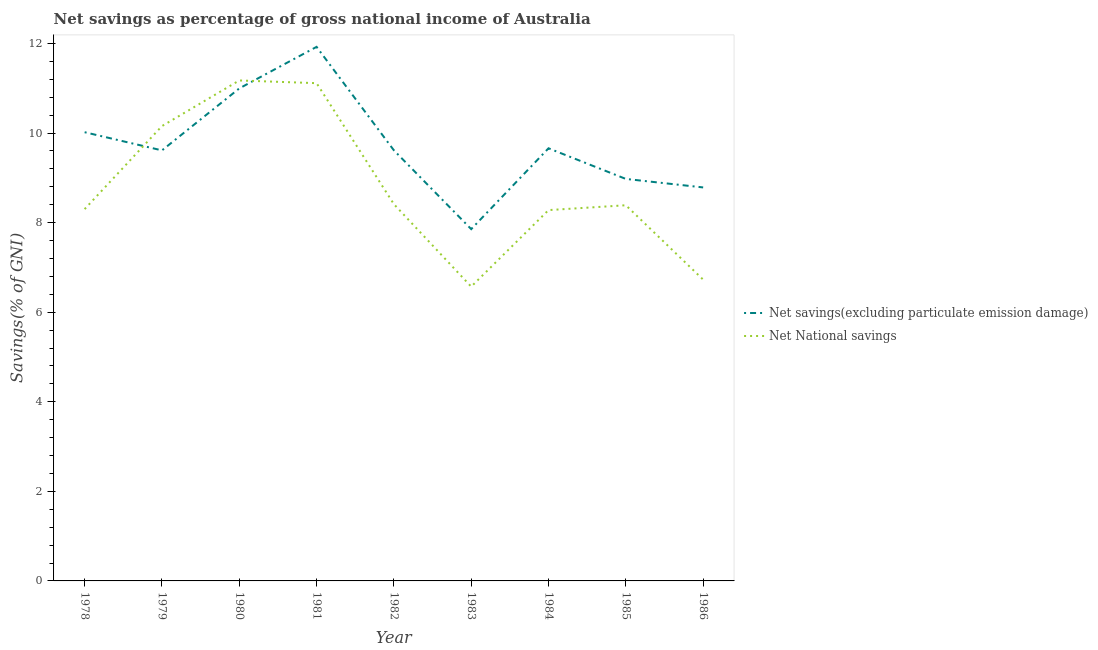Does the line corresponding to net savings(excluding particulate emission damage) intersect with the line corresponding to net national savings?
Your answer should be very brief. Yes. What is the net national savings in 1978?
Make the answer very short. 8.3. Across all years, what is the maximum net savings(excluding particulate emission damage)?
Your answer should be compact. 11.92. Across all years, what is the minimum net national savings?
Provide a succinct answer. 6.57. In which year was the net savings(excluding particulate emission damage) maximum?
Offer a terse response. 1981. In which year was the net savings(excluding particulate emission damage) minimum?
Your answer should be very brief. 1983. What is the total net national savings in the graph?
Provide a succinct answer. 79.13. What is the difference between the net savings(excluding particulate emission damage) in 1979 and that in 1986?
Ensure brevity in your answer.  0.83. What is the difference between the net savings(excluding particulate emission damage) in 1983 and the net national savings in 1982?
Keep it short and to the point. -0.56. What is the average net savings(excluding particulate emission damage) per year?
Offer a very short reply. 9.72. In the year 1979, what is the difference between the net savings(excluding particulate emission damage) and net national savings?
Offer a very short reply. -0.54. What is the ratio of the net national savings in 1978 to that in 1982?
Offer a terse response. 0.99. What is the difference between the highest and the second highest net national savings?
Provide a short and direct response. 0.06. What is the difference between the highest and the lowest net national savings?
Your answer should be compact. 4.6. In how many years, is the net savings(excluding particulate emission damage) greater than the average net savings(excluding particulate emission damage) taken over all years?
Your answer should be very brief. 3. Is the sum of the net savings(excluding particulate emission damage) in 1982 and 1985 greater than the maximum net national savings across all years?
Your answer should be very brief. Yes. Does the net savings(excluding particulate emission damage) monotonically increase over the years?
Offer a very short reply. No. Is the net savings(excluding particulate emission damage) strictly greater than the net national savings over the years?
Keep it short and to the point. No. Is the net national savings strictly less than the net savings(excluding particulate emission damage) over the years?
Offer a terse response. No. How many lines are there?
Provide a succinct answer. 2. Are the values on the major ticks of Y-axis written in scientific E-notation?
Provide a succinct answer. No. Does the graph contain grids?
Ensure brevity in your answer.  No. Where does the legend appear in the graph?
Your answer should be very brief. Center right. How are the legend labels stacked?
Offer a very short reply. Vertical. What is the title of the graph?
Provide a succinct answer. Net savings as percentage of gross national income of Australia. Does "Tetanus" appear as one of the legend labels in the graph?
Provide a succinct answer. No. What is the label or title of the Y-axis?
Provide a succinct answer. Savings(% of GNI). What is the Savings(% of GNI) in Net savings(excluding particulate emission damage) in 1978?
Ensure brevity in your answer.  10.02. What is the Savings(% of GNI) of Net National savings in 1978?
Keep it short and to the point. 8.3. What is the Savings(% of GNI) of Net savings(excluding particulate emission damage) in 1979?
Give a very brief answer. 9.61. What is the Savings(% of GNI) of Net National savings in 1979?
Offer a terse response. 10.16. What is the Savings(% of GNI) in Net savings(excluding particulate emission damage) in 1980?
Provide a succinct answer. 11. What is the Savings(% of GNI) of Net National savings in 1980?
Keep it short and to the point. 11.17. What is the Savings(% of GNI) of Net savings(excluding particulate emission damage) in 1981?
Your response must be concise. 11.92. What is the Savings(% of GNI) in Net National savings in 1981?
Provide a short and direct response. 11.11. What is the Savings(% of GNI) in Net savings(excluding particulate emission damage) in 1982?
Your response must be concise. 9.61. What is the Savings(% of GNI) in Net National savings in 1982?
Your answer should be compact. 8.41. What is the Savings(% of GNI) in Net savings(excluding particulate emission damage) in 1983?
Provide a short and direct response. 7.85. What is the Savings(% of GNI) in Net National savings in 1983?
Make the answer very short. 6.57. What is the Savings(% of GNI) in Net savings(excluding particulate emission damage) in 1984?
Offer a very short reply. 9.66. What is the Savings(% of GNI) in Net National savings in 1984?
Give a very brief answer. 8.28. What is the Savings(% of GNI) in Net savings(excluding particulate emission damage) in 1985?
Give a very brief answer. 8.98. What is the Savings(% of GNI) in Net National savings in 1985?
Provide a succinct answer. 8.39. What is the Savings(% of GNI) of Net savings(excluding particulate emission damage) in 1986?
Ensure brevity in your answer.  8.79. What is the Savings(% of GNI) in Net National savings in 1986?
Your response must be concise. 6.73. Across all years, what is the maximum Savings(% of GNI) in Net savings(excluding particulate emission damage)?
Your answer should be very brief. 11.92. Across all years, what is the maximum Savings(% of GNI) in Net National savings?
Ensure brevity in your answer.  11.17. Across all years, what is the minimum Savings(% of GNI) of Net savings(excluding particulate emission damage)?
Offer a terse response. 7.85. Across all years, what is the minimum Savings(% of GNI) of Net National savings?
Make the answer very short. 6.57. What is the total Savings(% of GNI) in Net savings(excluding particulate emission damage) in the graph?
Give a very brief answer. 87.45. What is the total Savings(% of GNI) of Net National savings in the graph?
Provide a short and direct response. 79.13. What is the difference between the Savings(% of GNI) in Net savings(excluding particulate emission damage) in 1978 and that in 1979?
Provide a short and direct response. 0.41. What is the difference between the Savings(% of GNI) in Net National savings in 1978 and that in 1979?
Your answer should be compact. -1.85. What is the difference between the Savings(% of GNI) of Net savings(excluding particulate emission damage) in 1978 and that in 1980?
Your answer should be compact. -0.98. What is the difference between the Savings(% of GNI) of Net National savings in 1978 and that in 1980?
Your response must be concise. -2.87. What is the difference between the Savings(% of GNI) of Net savings(excluding particulate emission damage) in 1978 and that in 1981?
Provide a short and direct response. -1.91. What is the difference between the Savings(% of GNI) of Net National savings in 1978 and that in 1981?
Your answer should be very brief. -2.81. What is the difference between the Savings(% of GNI) of Net savings(excluding particulate emission damage) in 1978 and that in 1982?
Make the answer very short. 0.4. What is the difference between the Savings(% of GNI) of Net National savings in 1978 and that in 1982?
Ensure brevity in your answer.  -0.11. What is the difference between the Savings(% of GNI) of Net savings(excluding particulate emission damage) in 1978 and that in 1983?
Your answer should be compact. 2.16. What is the difference between the Savings(% of GNI) in Net National savings in 1978 and that in 1983?
Your answer should be compact. 1.73. What is the difference between the Savings(% of GNI) of Net savings(excluding particulate emission damage) in 1978 and that in 1984?
Give a very brief answer. 0.36. What is the difference between the Savings(% of GNI) in Net National savings in 1978 and that in 1984?
Your answer should be compact. 0.02. What is the difference between the Savings(% of GNI) of Net savings(excluding particulate emission damage) in 1978 and that in 1985?
Provide a short and direct response. 1.04. What is the difference between the Savings(% of GNI) in Net National savings in 1978 and that in 1985?
Ensure brevity in your answer.  -0.09. What is the difference between the Savings(% of GNI) in Net savings(excluding particulate emission damage) in 1978 and that in 1986?
Keep it short and to the point. 1.23. What is the difference between the Savings(% of GNI) of Net National savings in 1978 and that in 1986?
Keep it short and to the point. 1.57. What is the difference between the Savings(% of GNI) of Net savings(excluding particulate emission damage) in 1979 and that in 1980?
Your response must be concise. -1.38. What is the difference between the Savings(% of GNI) of Net National savings in 1979 and that in 1980?
Make the answer very short. -1.02. What is the difference between the Savings(% of GNI) in Net savings(excluding particulate emission damage) in 1979 and that in 1981?
Offer a terse response. -2.31. What is the difference between the Savings(% of GNI) in Net National savings in 1979 and that in 1981?
Provide a succinct answer. -0.96. What is the difference between the Savings(% of GNI) of Net savings(excluding particulate emission damage) in 1979 and that in 1982?
Ensure brevity in your answer.  -0. What is the difference between the Savings(% of GNI) of Net National savings in 1979 and that in 1982?
Make the answer very short. 1.74. What is the difference between the Savings(% of GNI) in Net savings(excluding particulate emission damage) in 1979 and that in 1983?
Provide a succinct answer. 1.76. What is the difference between the Savings(% of GNI) of Net National savings in 1979 and that in 1983?
Ensure brevity in your answer.  3.58. What is the difference between the Savings(% of GNI) of Net savings(excluding particulate emission damage) in 1979 and that in 1984?
Keep it short and to the point. -0.05. What is the difference between the Savings(% of GNI) of Net National savings in 1979 and that in 1984?
Your answer should be compact. 1.88. What is the difference between the Savings(% of GNI) of Net savings(excluding particulate emission damage) in 1979 and that in 1985?
Your response must be concise. 0.64. What is the difference between the Savings(% of GNI) of Net National savings in 1979 and that in 1985?
Offer a terse response. 1.77. What is the difference between the Savings(% of GNI) of Net savings(excluding particulate emission damage) in 1979 and that in 1986?
Keep it short and to the point. 0.83. What is the difference between the Savings(% of GNI) of Net National savings in 1979 and that in 1986?
Your answer should be very brief. 3.43. What is the difference between the Savings(% of GNI) in Net savings(excluding particulate emission damage) in 1980 and that in 1981?
Your response must be concise. -0.93. What is the difference between the Savings(% of GNI) in Net National savings in 1980 and that in 1981?
Provide a short and direct response. 0.06. What is the difference between the Savings(% of GNI) in Net savings(excluding particulate emission damage) in 1980 and that in 1982?
Offer a very short reply. 1.38. What is the difference between the Savings(% of GNI) in Net National savings in 1980 and that in 1982?
Provide a short and direct response. 2.76. What is the difference between the Savings(% of GNI) in Net savings(excluding particulate emission damage) in 1980 and that in 1983?
Keep it short and to the point. 3.14. What is the difference between the Savings(% of GNI) in Net National savings in 1980 and that in 1983?
Offer a terse response. 4.6. What is the difference between the Savings(% of GNI) of Net savings(excluding particulate emission damage) in 1980 and that in 1984?
Keep it short and to the point. 1.34. What is the difference between the Savings(% of GNI) of Net National savings in 1980 and that in 1984?
Your response must be concise. 2.89. What is the difference between the Savings(% of GNI) in Net savings(excluding particulate emission damage) in 1980 and that in 1985?
Your answer should be compact. 2.02. What is the difference between the Savings(% of GNI) of Net National savings in 1980 and that in 1985?
Your response must be concise. 2.79. What is the difference between the Savings(% of GNI) of Net savings(excluding particulate emission damage) in 1980 and that in 1986?
Offer a terse response. 2.21. What is the difference between the Savings(% of GNI) of Net National savings in 1980 and that in 1986?
Offer a very short reply. 4.45. What is the difference between the Savings(% of GNI) in Net savings(excluding particulate emission damage) in 1981 and that in 1982?
Give a very brief answer. 2.31. What is the difference between the Savings(% of GNI) of Net National savings in 1981 and that in 1982?
Your answer should be very brief. 2.7. What is the difference between the Savings(% of GNI) of Net savings(excluding particulate emission damage) in 1981 and that in 1983?
Ensure brevity in your answer.  4.07. What is the difference between the Savings(% of GNI) in Net National savings in 1981 and that in 1983?
Keep it short and to the point. 4.54. What is the difference between the Savings(% of GNI) in Net savings(excluding particulate emission damage) in 1981 and that in 1984?
Your answer should be compact. 2.26. What is the difference between the Savings(% of GNI) in Net National savings in 1981 and that in 1984?
Ensure brevity in your answer.  2.83. What is the difference between the Savings(% of GNI) of Net savings(excluding particulate emission damage) in 1981 and that in 1985?
Keep it short and to the point. 2.95. What is the difference between the Savings(% of GNI) in Net National savings in 1981 and that in 1985?
Provide a short and direct response. 2.73. What is the difference between the Savings(% of GNI) in Net savings(excluding particulate emission damage) in 1981 and that in 1986?
Make the answer very short. 3.14. What is the difference between the Savings(% of GNI) in Net National savings in 1981 and that in 1986?
Provide a short and direct response. 4.39. What is the difference between the Savings(% of GNI) in Net savings(excluding particulate emission damage) in 1982 and that in 1983?
Give a very brief answer. 1.76. What is the difference between the Savings(% of GNI) in Net National savings in 1982 and that in 1983?
Your answer should be very brief. 1.84. What is the difference between the Savings(% of GNI) of Net savings(excluding particulate emission damage) in 1982 and that in 1984?
Offer a terse response. -0.05. What is the difference between the Savings(% of GNI) in Net National savings in 1982 and that in 1984?
Provide a short and direct response. 0.13. What is the difference between the Savings(% of GNI) in Net savings(excluding particulate emission damage) in 1982 and that in 1985?
Provide a succinct answer. 0.64. What is the difference between the Savings(% of GNI) in Net National savings in 1982 and that in 1985?
Keep it short and to the point. 0.02. What is the difference between the Savings(% of GNI) of Net savings(excluding particulate emission damage) in 1982 and that in 1986?
Your answer should be very brief. 0.83. What is the difference between the Savings(% of GNI) of Net National savings in 1982 and that in 1986?
Keep it short and to the point. 1.68. What is the difference between the Savings(% of GNI) of Net savings(excluding particulate emission damage) in 1983 and that in 1984?
Keep it short and to the point. -1.81. What is the difference between the Savings(% of GNI) of Net National savings in 1983 and that in 1984?
Give a very brief answer. -1.71. What is the difference between the Savings(% of GNI) in Net savings(excluding particulate emission damage) in 1983 and that in 1985?
Offer a terse response. -1.12. What is the difference between the Savings(% of GNI) in Net National savings in 1983 and that in 1985?
Your answer should be compact. -1.82. What is the difference between the Savings(% of GNI) in Net savings(excluding particulate emission damage) in 1983 and that in 1986?
Give a very brief answer. -0.93. What is the difference between the Savings(% of GNI) in Net National savings in 1983 and that in 1986?
Offer a terse response. -0.16. What is the difference between the Savings(% of GNI) of Net savings(excluding particulate emission damage) in 1984 and that in 1985?
Keep it short and to the point. 0.68. What is the difference between the Savings(% of GNI) in Net National savings in 1984 and that in 1985?
Offer a terse response. -0.11. What is the difference between the Savings(% of GNI) of Net savings(excluding particulate emission damage) in 1984 and that in 1986?
Provide a short and direct response. 0.87. What is the difference between the Savings(% of GNI) of Net National savings in 1984 and that in 1986?
Give a very brief answer. 1.55. What is the difference between the Savings(% of GNI) of Net savings(excluding particulate emission damage) in 1985 and that in 1986?
Ensure brevity in your answer.  0.19. What is the difference between the Savings(% of GNI) of Net National savings in 1985 and that in 1986?
Offer a terse response. 1.66. What is the difference between the Savings(% of GNI) of Net savings(excluding particulate emission damage) in 1978 and the Savings(% of GNI) of Net National savings in 1979?
Provide a succinct answer. -0.14. What is the difference between the Savings(% of GNI) of Net savings(excluding particulate emission damage) in 1978 and the Savings(% of GNI) of Net National savings in 1980?
Your answer should be very brief. -1.16. What is the difference between the Savings(% of GNI) of Net savings(excluding particulate emission damage) in 1978 and the Savings(% of GNI) of Net National savings in 1981?
Provide a succinct answer. -1.09. What is the difference between the Savings(% of GNI) in Net savings(excluding particulate emission damage) in 1978 and the Savings(% of GNI) in Net National savings in 1982?
Offer a very short reply. 1.61. What is the difference between the Savings(% of GNI) of Net savings(excluding particulate emission damage) in 1978 and the Savings(% of GNI) of Net National savings in 1983?
Offer a terse response. 3.45. What is the difference between the Savings(% of GNI) of Net savings(excluding particulate emission damage) in 1978 and the Savings(% of GNI) of Net National savings in 1984?
Offer a terse response. 1.74. What is the difference between the Savings(% of GNI) of Net savings(excluding particulate emission damage) in 1978 and the Savings(% of GNI) of Net National savings in 1985?
Provide a succinct answer. 1.63. What is the difference between the Savings(% of GNI) of Net savings(excluding particulate emission damage) in 1978 and the Savings(% of GNI) of Net National savings in 1986?
Provide a short and direct response. 3.29. What is the difference between the Savings(% of GNI) of Net savings(excluding particulate emission damage) in 1979 and the Savings(% of GNI) of Net National savings in 1980?
Give a very brief answer. -1.56. What is the difference between the Savings(% of GNI) of Net savings(excluding particulate emission damage) in 1979 and the Savings(% of GNI) of Net National savings in 1981?
Make the answer very short. -1.5. What is the difference between the Savings(% of GNI) of Net savings(excluding particulate emission damage) in 1979 and the Savings(% of GNI) of Net National savings in 1982?
Provide a succinct answer. 1.2. What is the difference between the Savings(% of GNI) in Net savings(excluding particulate emission damage) in 1979 and the Savings(% of GNI) in Net National savings in 1983?
Your answer should be very brief. 3.04. What is the difference between the Savings(% of GNI) in Net savings(excluding particulate emission damage) in 1979 and the Savings(% of GNI) in Net National savings in 1984?
Offer a very short reply. 1.33. What is the difference between the Savings(% of GNI) of Net savings(excluding particulate emission damage) in 1979 and the Savings(% of GNI) of Net National savings in 1985?
Keep it short and to the point. 1.22. What is the difference between the Savings(% of GNI) in Net savings(excluding particulate emission damage) in 1979 and the Savings(% of GNI) in Net National savings in 1986?
Make the answer very short. 2.89. What is the difference between the Savings(% of GNI) in Net savings(excluding particulate emission damage) in 1980 and the Savings(% of GNI) in Net National savings in 1981?
Your answer should be very brief. -0.12. What is the difference between the Savings(% of GNI) of Net savings(excluding particulate emission damage) in 1980 and the Savings(% of GNI) of Net National savings in 1982?
Your answer should be very brief. 2.58. What is the difference between the Savings(% of GNI) of Net savings(excluding particulate emission damage) in 1980 and the Savings(% of GNI) of Net National savings in 1983?
Offer a terse response. 4.43. What is the difference between the Savings(% of GNI) of Net savings(excluding particulate emission damage) in 1980 and the Savings(% of GNI) of Net National savings in 1984?
Keep it short and to the point. 2.72. What is the difference between the Savings(% of GNI) in Net savings(excluding particulate emission damage) in 1980 and the Savings(% of GNI) in Net National savings in 1985?
Give a very brief answer. 2.61. What is the difference between the Savings(% of GNI) of Net savings(excluding particulate emission damage) in 1980 and the Savings(% of GNI) of Net National savings in 1986?
Provide a short and direct response. 4.27. What is the difference between the Savings(% of GNI) in Net savings(excluding particulate emission damage) in 1981 and the Savings(% of GNI) in Net National savings in 1982?
Offer a terse response. 3.51. What is the difference between the Savings(% of GNI) of Net savings(excluding particulate emission damage) in 1981 and the Savings(% of GNI) of Net National savings in 1983?
Offer a terse response. 5.35. What is the difference between the Savings(% of GNI) in Net savings(excluding particulate emission damage) in 1981 and the Savings(% of GNI) in Net National savings in 1984?
Make the answer very short. 3.64. What is the difference between the Savings(% of GNI) of Net savings(excluding particulate emission damage) in 1981 and the Savings(% of GNI) of Net National savings in 1985?
Give a very brief answer. 3.54. What is the difference between the Savings(% of GNI) in Net savings(excluding particulate emission damage) in 1981 and the Savings(% of GNI) in Net National savings in 1986?
Your answer should be compact. 5.2. What is the difference between the Savings(% of GNI) of Net savings(excluding particulate emission damage) in 1982 and the Savings(% of GNI) of Net National savings in 1983?
Ensure brevity in your answer.  3.04. What is the difference between the Savings(% of GNI) in Net savings(excluding particulate emission damage) in 1982 and the Savings(% of GNI) in Net National savings in 1984?
Make the answer very short. 1.33. What is the difference between the Savings(% of GNI) of Net savings(excluding particulate emission damage) in 1982 and the Savings(% of GNI) of Net National savings in 1985?
Your answer should be compact. 1.23. What is the difference between the Savings(% of GNI) in Net savings(excluding particulate emission damage) in 1982 and the Savings(% of GNI) in Net National savings in 1986?
Your response must be concise. 2.89. What is the difference between the Savings(% of GNI) of Net savings(excluding particulate emission damage) in 1983 and the Savings(% of GNI) of Net National savings in 1984?
Ensure brevity in your answer.  -0.42. What is the difference between the Savings(% of GNI) of Net savings(excluding particulate emission damage) in 1983 and the Savings(% of GNI) of Net National savings in 1985?
Provide a succinct answer. -0.53. What is the difference between the Savings(% of GNI) in Net savings(excluding particulate emission damage) in 1983 and the Savings(% of GNI) in Net National savings in 1986?
Keep it short and to the point. 1.13. What is the difference between the Savings(% of GNI) of Net savings(excluding particulate emission damage) in 1984 and the Savings(% of GNI) of Net National savings in 1985?
Make the answer very short. 1.27. What is the difference between the Savings(% of GNI) in Net savings(excluding particulate emission damage) in 1984 and the Savings(% of GNI) in Net National savings in 1986?
Keep it short and to the point. 2.93. What is the difference between the Savings(% of GNI) in Net savings(excluding particulate emission damage) in 1985 and the Savings(% of GNI) in Net National savings in 1986?
Your response must be concise. 2.25. What is the average Savings(% of GNI) of Net savings(excluding particulate emission damage) per year?
Provide a short and direct response. 9.72. What is the average Savings(% of GNI) in Net National savings per year?
Ensure brevity in your answer.  8.79. In the year 1978, what is the difference between the Savings(% of GNI) of Net savings(excluding particulate emission damage) and Savings(% of GNI) of Net National savings?
Make the answer very short. 1.72. In the year 1979, what is the difference between the Savings(% of GNI) in Net savings(excluding particulate emission damage) and Savings(% of GNI) in Net National savings?
Your answer should be very brief. -0.54. In the year 1980, what is the difference between the Savings(% of GNI) in Net savings(excluding particulate emission damage) and Savings(% of GNI) in Net National savings?
Your answer should be very brief. -0.18. In the year 1981, what is the difference between the Savings(% of GNI) of Net savings(excluding particulate emission damage) and Savings(% of GNI) of Net National savings?
Ensure brevity in your answer.  0.81. In the year 1982, what is the difference between the Savings(% of GNI) of Net savings(excluding particulate emission damage) and Savings(% of GNI) of Net National savings?
Provide a short and direct response. 1.2. In the year 1983, what is the difference between the Savings(% of GNI) in Net savings(excluding particulate emission damage) and Savings(% of GNI) in Net National savings?
Your answer should be very brief. 1.28. In the year 1984, what is the difference between the Savings(% of GNI) in Net savings(excluding particulate emission damage) and Savings(% of GNI) in Net National savings?
Your answer should be very brief. 1.38. In the year 1985, what is the difference between the Savings(% of GNI) in Net savings(excluding particulate emission damage) and Savings(% of GNI) in Net National savings?
Your answer should be very brief. 0.59. In the year 1986, what is the difference between the Savings(% of GNI) in Net savings(excluding particulate emission damage) and Savings(% of GNI) in Net National savings?
Your answer should be compact. 2.06. What is the ratio of the Savings(% of GNI) of Net savings(excluding particulate emission damage) in 1978 to that in 1979?
Provide a short and direct response. 1.04. What is the ratio of the Savings(% of GNI) in Net National savings in 1978 to that in 1979?
Provide a succinct answer. 0.82. What is the ratio of the Savings(% of GNI) of Net savings(excluding particulate emission damage) in 1978 to that in 1980?
Provide a succinct answer. 0.91. What is the ratio of the Savings(% of GNI) in Net National savings in 1978 to that in 1980?
Make the answer very short. 0.74. What is the ratio of the Savings(% of GNI) in Net savings(excluding particulate emission damage) in 1978 to that in 1981?
Offer a terse response. 0.84. What is the ratio of the Savings(% of GNI) of Net National savings in 1978 to that in 1981?
Your answer should be very brief. 0.75. What is the ratio of the Savings(% of GNI) of Net savings(excluding particulate emission damage) in 1978 to that in 1982?
Your response must be concise. 1.04. What is the ratio of the Savings(% of GNI) in Net National savings in 1978 to that in 1982?
Ensure brevity in your answer.  0.99. What is the ratio of the Savings(% of GNI) of Net savings(excluding particulate emission damage) in 1978 to that in 1983?
Your answer should be compact. 1.28. What is the ratio of the Savings(% of GNI) of Net National savings in 1978 to that in 1983?
Your answer should be very brief. 1.26. What is the ratio of the Savings(% of GNI) of Net savings(excluding particulate emission damage) in 1978 to that in 1984?
Ensure brevity in your answer.  1.04. What is the ratio of the Savings(% of GNI) in Net savings(excluding particulate emission damage) in 1978 to that in 1985?
Offer a very short reply. 1.12. What is the ratio of the Savings(% of GNI) in Net National savings in 1978 to that in 1985?
Your answer should be compact. 0.99. What is the ratio of the Savings(% of GNI) in Net savings(excluding particulate emission damage) in 1978 to that in 1986?
Provide a short and direct response. 1.14. What is the ratio of the Savings(% of GNI) of Net National savings in 1978 to that in 1986?
Give a very brief answer. 1.23. What is the ratio of the Savings(% of GNI) in Net savings(excluding particulate emission damage) in 1979 to that in 1980?
Provide a short and direct response. 0.87. What is the ratio of the Savings(% of GNI) of Net National savings in 1979 to that in 1980?
Offer a very short reply. 0.91. What is the ratio of the Savings(% of GNI) of Net savings(excluding particulate emission damage) in 1979 to that in 1981?
Provide a succinct answer. 0.81. What is the ratio of the Savings(% of GNI) of Net National savings in 1979 to that in 1981?
Offer a very short reply. 0.91. What is the ratio of the Savings(% of GNI) in Net savings(excluding particulate emission damage) in 1979 to that in 1982?
Provide a short and direct response. 1. What is the ratio of the Savings(% of GNI) of Net National savings in 1979 to that in 1982?
Provide a succinct answer. 1.21. What is the ratio of the Savings(% of GNI) in Net savings(excluding particulate emission damage) in 1979 to that in 1983?
Offer a very short reply. 1.22. What is the ratio of the Savings(% of GNI) of Net National savings in 1979 to that in 1983?
Offer a very short reply. 1.55. What is the ratio of the Savings(% of GNI) in Net National savings in 1979 to that in 1984?
Make the answer very short. 1.23. What is the ratio of the Savings(% of GNI) in Net savings(excluding particulate emission damage) in 1979 to that in 1985?
Your response must be concise. 1.07. What is the ratio of the Savings(% of GNI) of Net National savings in 1979 to that in 1985?
Provide a succinct answer. 1.21. What is the ratio of the Savings(% of GNI) of Net savings(excluding particulate emission damage) in 1979 to that in 1986?
Offer a terse response. 1.09. What is the ratio of the Savings(% of GNI) of Net National savings in 1979 to that in 1986?
Ensure brevity in your answer.  1.51. What is the ratio of the Savings(% of GNI) of Net savings(excluding particulate emission damage) in 1980 to that in 1981?
Keep it short and to the point. 0.92. What is the ratio of the Savings(% of GNI) in Net savings(excluding particulate emission damage) in 1980 to that in 1982?
Your answer should be compact. 1.14. What is the ratio of the Savings(% of GNI) in Net National savings in 1980 to that in 1982?
Keep it short and to the point. 1.33. What is the ratio of the Savings(% of GNI) of Net National savings in 1980 to that in 1983?
Your answer should be compact. 1.7. What is the ratio of the Savings(% of GNI) of Net savings(excluding particulate emission damage) in 1980 to that in 1984?
Make the answer very short. 1.14. What is the ratio of the Savings(% of GNI) in Net National savings in 1980 to that in 1984?
Provide a succinct answer. 1.35. What is the ratio of the Savings(% of GNI) in Net savings(excluding particulate emission damage) in 1980 to that in 1985?
Your answer should be very brief. 1.23. What is the ratio of the Savings(% of GNI) of Net National savings in 1980 to that in 1985?
Keep it short and to the point. 1.33. What is the ratio of the Savings(% of GNI) in Net savings(excluding particulate emission damage) in 1980 to that in 1986?
Make the answer very short. 1.25. What is the ratio of the Savings(% of GNI) in Net National savings in 1980 to that in 1986?
Make the answer very short. 1.66. What is the ratio of the Savings(% of GNI) in Net savings(excluding particulate emission damage) in 1981 to that in 1982?
Offer a terse response. 1.24. What is the ratio of the Savings(% of GNI) in Net National savings in 1981 to that in 1982?
Offer a terse response. 1.32. What is the ratio of the Savings(% of GNI) of Net savings(excluding particulate emission damage) in 1981 to that in 1983?
Provide a short and direct response. 1.52. What is the ratio of the Savings(% of GNI) in Net National savings in 1981 to that in 1983?
Ensure brevity in your answer.  1.69. What is the ratio of the Savings(% of GNI) of Net savings(excluding particulate emission damage) in 1981 to that in 1984?
Make the answer very short. 1.23. What is the ratio of the Savings(% of GNI) in Net National savings in 1981 to that in 1984?
Give a very brief answer. 1.34. What is the ratio of the Savings(% of GNI) in Net savings(excluding particulate emission damage) in 1981 to that in 1985?
Keep it short and to the point. 1.33. What is the ratio of the Savings(% of GNI) of Net National savings in 1981 to that in 1985?
Provide a succinct answer. 1.32. What is the ratio of the Savings(% of GNI) of Net savings(excluding particulate emission damage) in 1981 to that in 1986?
Your answer should be very brief. 1.36. What is the ratio of the Savings(% of GNI) in Net National savings in 1981 to that in 1986?
Offer a terse response. 1.65. What is the ratio of the Savings(% of GNI) in Net savings(excluding particulate emission damage) in 1982 to that in 1983?
Provide a short and direct response. 1.22. What is the ratio of the Savings(% of GNI) of Net National savings in 1982 to that in 1983?
Provide a succinct answer. 1.28. What is the ratio of the Savings(% of GNI) of Net savings(excluding particulate emission damage) in 1982 to that in 1985?
Provide a succinct answer. 1.07. What is the ratio of the Savings(% of GNI) in Net savings(excluding particulate emission damage) in 1982 to that in 1986?
Your response must be concise. 1.09. What is the ratio of the Savings(% of GNI) of Net National savings in 1982 to that in 1986?
Provide a short and direct response. 1.25. What is the ratio of the Savings(% of GNI) in Net savings(excluding particulate emission damage) in 1983 to that in 1984?
Your answer should be compact. 0.81. What is the ratio of the Savings(% of GNI) of Net National savings in 1983 to that in 1984?
Your answer should be compact. 0.79. What is the ratio of the Savings(% of GNI) of Net savings(excluding particulate emission damage) in 1983 to that in 1985?
Your answer should be compact. 0.88. What is the ratio of the Savings(% of GNI) of Net National savings in 1983 to that in 1985?
Your answer should be compact. 0.78. What is the ratio of the Savings(% of GNI) of Net savings(excluding particulate emission damage) in 1983 to that in 1986?
Keep it short and to the point. 0.89. What is the ratio of the Savings(% of GNI) in Net National savings in 1983 to that in 1986?
Your response must be concise. 0.98. What is the ratio of the Savings(% of GNI) in Net savings(excluding particulate emission damage) in 1984 to that in 1985?
Make the answer very short. 1.08. What is the ratio of the Savings(% of GNI) of Net National savings in 1984 to that in 1985?
Keep it short and to the point. 0.99. What is the ratio of the Savings(% of GNI) in Net savings(excluding particulate emission damage) in 1984 to that in 1986?
Keep it short and to the point. 1.1. What is the ratio of the Savings(% of GNI) of Net National savings in 1984 to that in 1986?
Make the answer very short. 1.23. What is the ratio of the Savings(% of GNI) in Net savings(excluding particulate emission damage) in 1985 to that in 1986?
Provide a succinct answer. 1.02. What is the ratio of the Savings(% of GNI) in Net National savings in 1985 to that in 1986?
Keep it short and to the point. 1.25. What is the difference between the highest and the second highest Savings(% of GNI) in Net savings(excluding particulate emission damage)?
Ensure brevity in your answer.  0.93. What is the difference between the highest and the second highest Savings(% of GNI) of Net National savings?
Provide a succinct answer. 0.06. What is the difference between the highest and the lowest Savings(% of GNI) in Net savings(excluding particulate emission damage)?
Keep it short and to the point. 4.07. What is the difference between the highest and the lowest Savings(% of GNI) of Net National savings?
Your response must be concise. 4.6. 